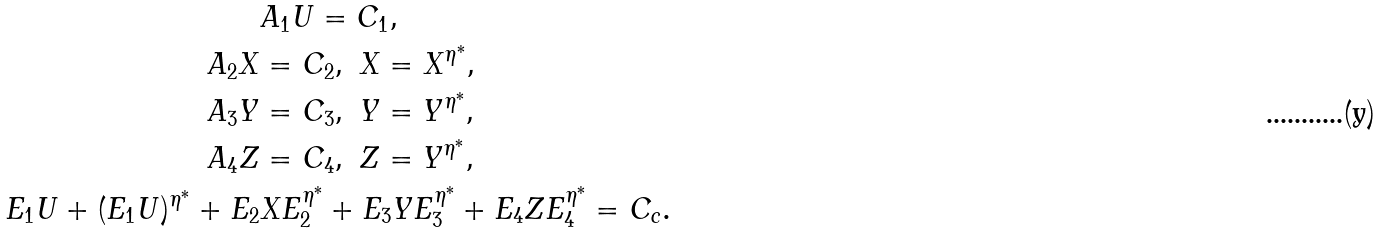<formula> <loc_0><loc_0><loc_500><loc_500>& A _ { 1 } U = C _ { 1 } , \\ A _ { 2 } X & = C _ { 2 } , \ X = X ^ { \eta ^ { \ast } } , \\ A _ { 3 } Y & = C _ { 3 } , \ Y = Y ^ { \eta ^ { \ast } } , \\ A _ { 4 } Z & = C _ { 4 } , \ Z = Y ^ { \eta ^ { \ast } } , \\ E _ { 1 } U + ( E _ { 1 } U ) ^ { \eta ^ { \ast } } + E _ { 2 } & X E _ { 2 } ^ { \eta ^ { \ast } } + E _ { 3 } Y E _ { 3 } ^ { \eta ^ { \ast } } + E _ { 4 } Z E _ { 4 } ^ { \eta ^ { \ast } } = C _ { c } .</formula> 